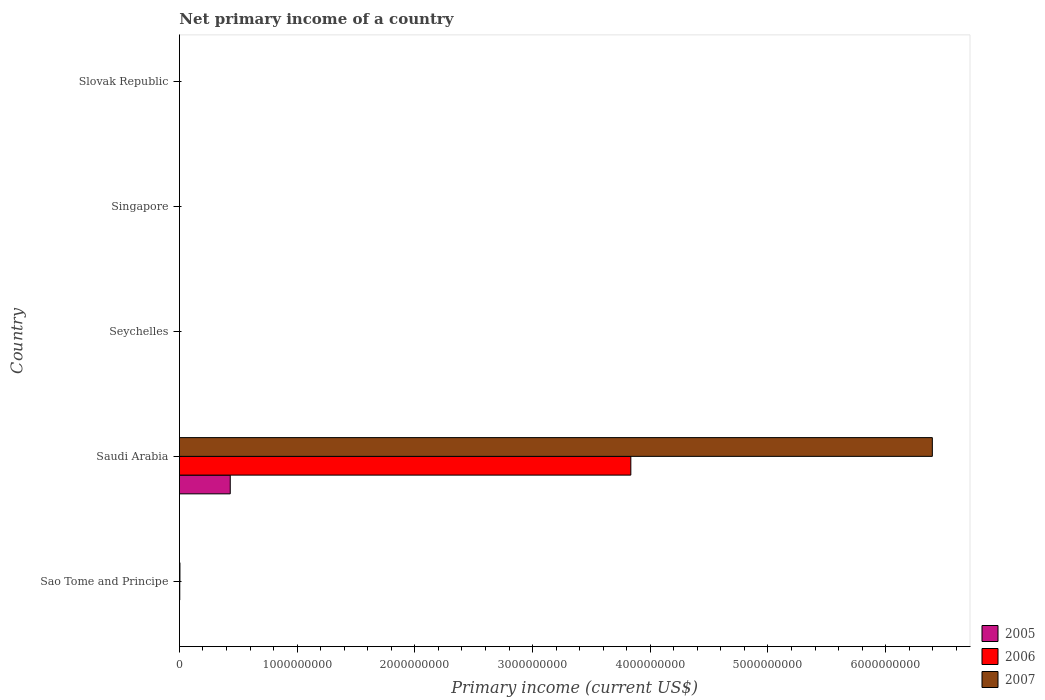How many different coloured bars are there?
Your answer should be very brief. 3. How many bars are there on the 3rd tick from the top?
Provide a succinct answer. 0. What is the label of the 4th group of bars from the top?
Ensure brevity in your answer.  Saudi Arabia. In how many cases, is the number of bars for a given country not equal to the number of legend labels?
Offer a terse response. 4. What is the primary income in 2006 in Saudi Arabia?
Make the answer very short. 3.83e+09. Across all countries, what is the maximum primary income in 2007?
Give a very brief answer. 6.40e+09. Across all countries, what is the minimum primary income in 2006?
Keep it short and to the point. 0. In which country was the primary income in 2006 maximum?
Your response must be concise. Saudi Arabia. What is the total primary income in 2005 in the graph?
Your answer should be compact. 4.32e+08. What is the difference between the primary income in 2006 in Sao Tome and Principe and that in Saudi Arabia?
Provide a succinct answer. -3.83e+09. What is the difference between the primary income in 2006 in Saudi Arabia and the primary income in 2007 in Sao Tome and Principe?
Provide a succinct answer. 3.83e+09. What is the average primary income in 2007 per country?
Keep it short and to the point. 1.28e+09. What is the difference between the primary income in 2005 and primary income in 2006 in Saudi Arabia?
Your response must be concise. -3.40e+09. Is the primary income in 2006 in Sao Tome and Principe less than that in Saudi Arabia?
Ensure brevity in your answer.  Yes. What is the difference between the highest and the lowest primary income in 2005?
Offer a very short reply. 4.32e+08. In how many countries, is the primary income in 2005 greater than the average primary income in 2005 taken over all countries?
Ensure brevity in your answer.  1. Is it the case that in every country, the sum of the primary income in 2007 and primary income in 2005 is greater than the primary income in 2006?
Offer a terse response. No. Are all the bars in the graph horizontal?
Your response must be concise. Yes. How many countries are there in the graph?
Offer a very short reply. 5. What is the difference between two consecutive major ticks on the X-axis?
Ensure brevity in your answer.  1.00e+09. Are the values on the major ticks of X-axis written in scientific E-notation?
Offer a very short reply. No. What is the title of the graph?
Your answer should be compact. Net primary income of a country. What is the label or title of the X-axis?
Keep it short and to the point. Primary income (current US$). What is the Primary income (current US$) of 2006 in Sao Tome and Principe?
Provide a succinct answer. 3.03e+06. What is the Primary income (current US$) of 2007 in Sao Tome and Principe?
Offer a terse response. 4.47e+06. What is the Primary income (current US$) in 2005 in Saudi Arabia?
Your response must be concise. 4.32e+08. What is the Primary income (current US$) in 2006 in Saudi Arabia?
Keep it short and to the point. 3.83e+09. What is the Primary income (current US$) in 2007 in Saudi Arabia?
Your response must be concise. 6.40e+09. What is the Primary income (current US$) of 2005 in Seychelles?
Keep it short and to the point. 0. What is the Primary income (current US$) of 2006 in Seychelles?
Your response must be concise. 0. What is the Primary income (current US$) of 2005 in Singapore?
Provide a short and direct response. 0. What is the Primary income (current US$) in 2007 in Singapore?
Give a very brief answer. 0. What is the Primary income (current US$) of 2007 in Slovak Republic?
Provide a succinct answer. 0. Across all countries, what is the maximum Primary income (current US$) of 2005?
Provide a short and direct response. 4.32e+08. Across all countries, what is the maximum Primary income (current US$) of 2006?
Make the answer very short. 3.83e+09. Across all countries, what is the maximum Primary income (current US$) in 2007?
Keep it short and to the point. 6.40e+09. Across all countries, what is the minimum Primary income (current US$) in 2007?
Make the answer very short. 0. What is the total Primary income (current US$) in 2005 in the graph?
Make the answer very short. 4.32e+08. What is the total Primary income (current US$) of 2006 in the graph?
Keep it short and to the point. 3.84e+09. What is the total Primary income (current US$) of 2007 in the graph?
Your response must be concise. 6.40e+09. What is the difference between the Primary income (current US$) of 2006 in Sao Tome and Principe and that in Saudi Arabia?
Your answer should be very brief. -3.83e+09. What is the difference between the Primary income (current US$) in 2007 in Sao Tome and Principe and that in Saudi Arabia?
Offer a very short reply. -6.39e+09. What is the difference between the Primary income (current US$) in 2006 in Sao Tome and Principe and the Primary income (current US$) in 2007 in Saudi Arabia?
Ensure brevity in your answer.  -6.39e+09. What is the average Primary income (current US$) in 2005 per country?
Ensure brevity in your answer.  8.64e+07. What is the average Primary income (current US$) in 2006 per country?
Make the answer very short. 7.68e+08. What is the average Primary income (current US$) of 2007 per country?
Ensure brevity in your answer.  1.28e+09. What is the difference between the Primary income (current US$) in 2006 and Primary income (current US$) in 2007 in Sao Tome and Principe?
Your answer should be compact. -1.44e+06. What is the difference between the Primary income (current US$) in 2005 and Primary income (current US$) in 2006 in Saudi Arabia?
Ensure brevity in your answer.  -3.40e+09. What is the difference between the Primary income (current US$) in 2005 and Primary income (current US$) in 2007 in Saudi Arabia?
Offer a terse response. -5.96e+09. What is the difference between the Primary income (current US$) in 2006 and Primary income (current US$) in 2007 in Saudi Arabia?
Provide a short and direct response. -2.56e+09. What is the ratio of the Primary income (current US$) in 2006 in Sao Tome and Principe to that in Saudi Arabia?
Your answer should be compact. 0. What is the ratio of the Primary income (current US$) of 2007 in Sao Tome and Principe to that in Saudi Arabia?
Offer a very short reply. 0. What is the difference between the highest and the lowest Primary income (current US$) of 2005?
Give a very brief answer. 4.32e+08. What is the difference between the highest and the lowest Primary income (current US$) in 2006?
Provide a short and direct response. 3.83e+09. What is the difference between the highest and the lowest Primary income (current US$) in 2007?
Your answer should be compact. 6.40e+09. 